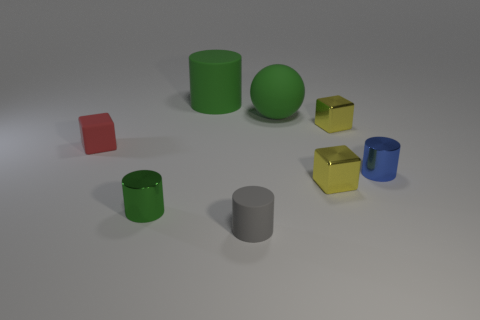Does the yellow metal thing that is behind the blue metal object have the same shape as the green object behind the green sphere?
Offer a very short reply. No. What number of objects are cyan matte balls or tiny things that are to the right of the red matte block?
Make the answer very short. 5. How many other things are the same size as the gray cylinder?
Provide a succinct answer. 5. Is the small blue object that is in front of the red object made of the same material as the green cylinder behind the big green ball?
Offer a very short reply. No. How many green cylinders are in front of the large green rubber sphere?
Keep it short and to the point. 1. What number of green things are either tiny objects or large rubber cylinders?
Ensure brevity in your answer.  2. There is a blue cylinder that is the same size as the gray thing; what is it made of?
Your response must be concise. Metal. There is a tiny thing that is behind the tiny blue thing and right of the gray matte cylinder; what shape is it?
Your response must be concise. Cube. There is a rubber cylinder that is the same size as the red matte block; what color is it?
Your response must be concise. Gray. Do the green thing that is right of the tiny gray cylinder and the thing behind the large green ball have the same size?
Your answer should be very brief. Yes. 